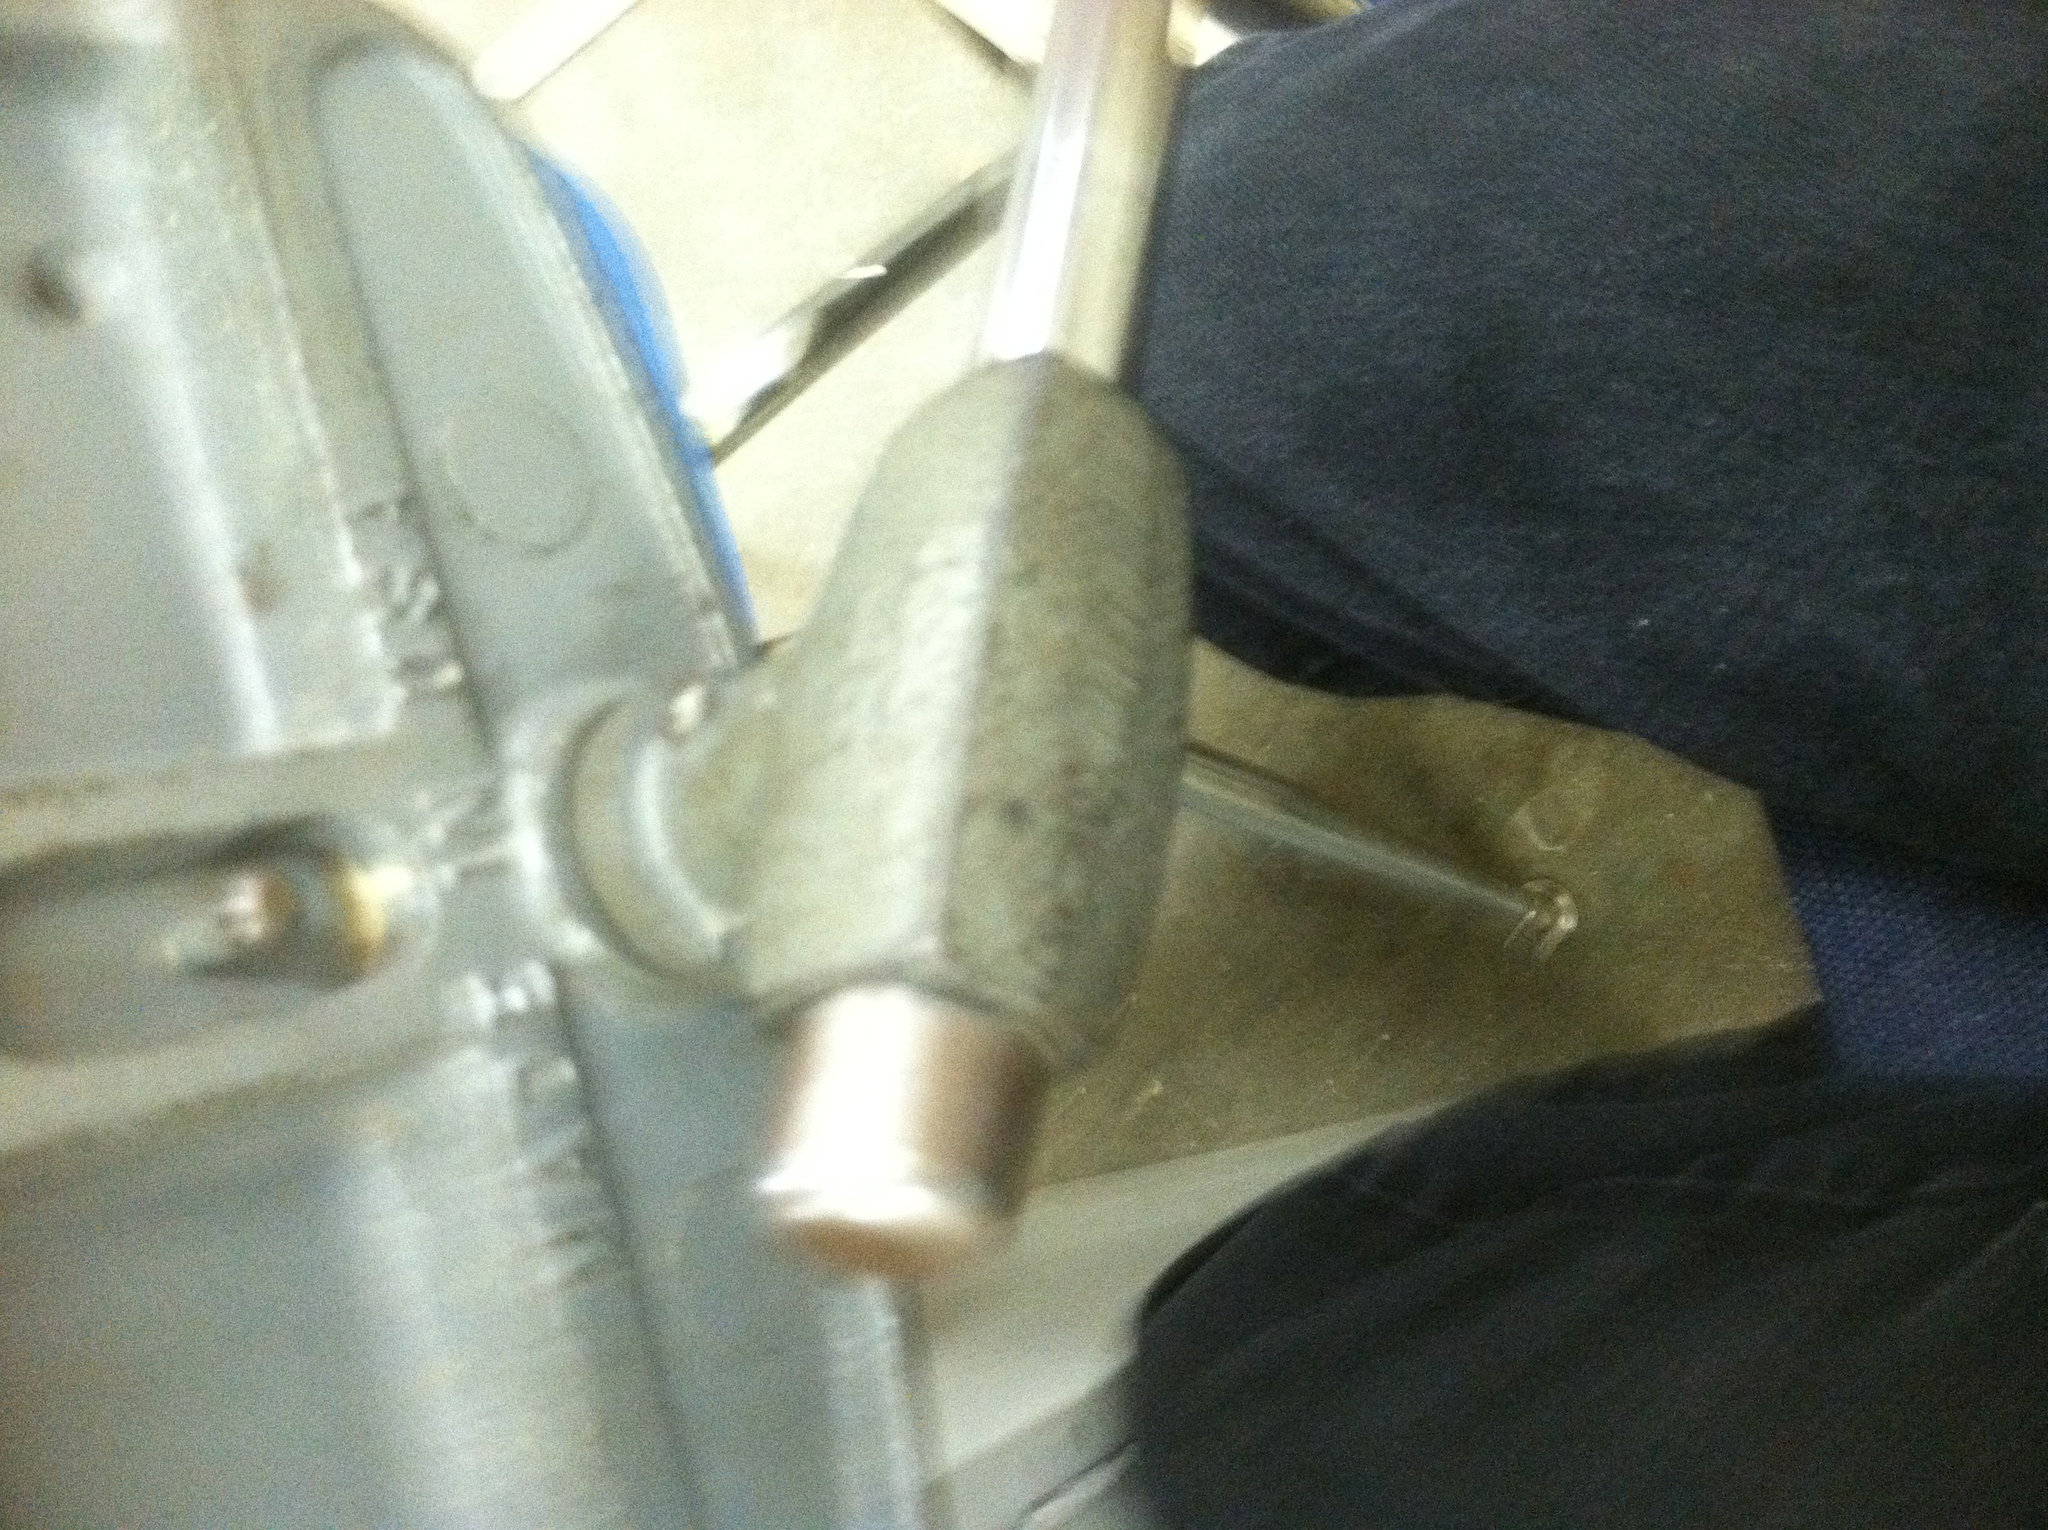Can you describe the function of this tool in more detail? Certainly! The tool in the image looks like a vise, which is a mechanical apparatus used to secure an object to allow work to be performed on it. It has two parallel jaws, one fixed and the other movable, threaded in and out by a screw or a lever. The object to be worked on is placed between these jaws and clamped tightly. Common applications include metalworking and woodworking, where it holds the material in place as it is cut, shaped, or drilled. Why is it important to use a vise during such tasks? Using a vise is crucial because it provides stability and precision, which are essential for safe and accurate work. When an object is securely held in place, there is less risk of slippage, which can lead to injuries or errors in the job being performed. Additionally, the firm hold allows for more precise cuts, drills, and shaping, ensuring that the final output meets the desired specifications. 